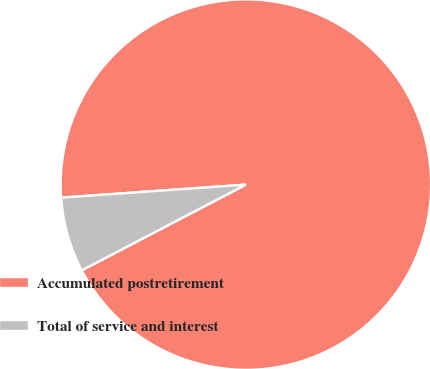Convert chart to OTSL. <chart><loc_0><loc_0><loc_500><loc_500><pie_chart><fcel>Accumulated postretirement<fcel>Total of service and interest<nl><fcel>93.46%<fcel>6.54%<nl></chart> 